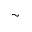Convert formula to latex. <formula><loc_0><loc_0><loc_500><loc_500>\sim</formula> 